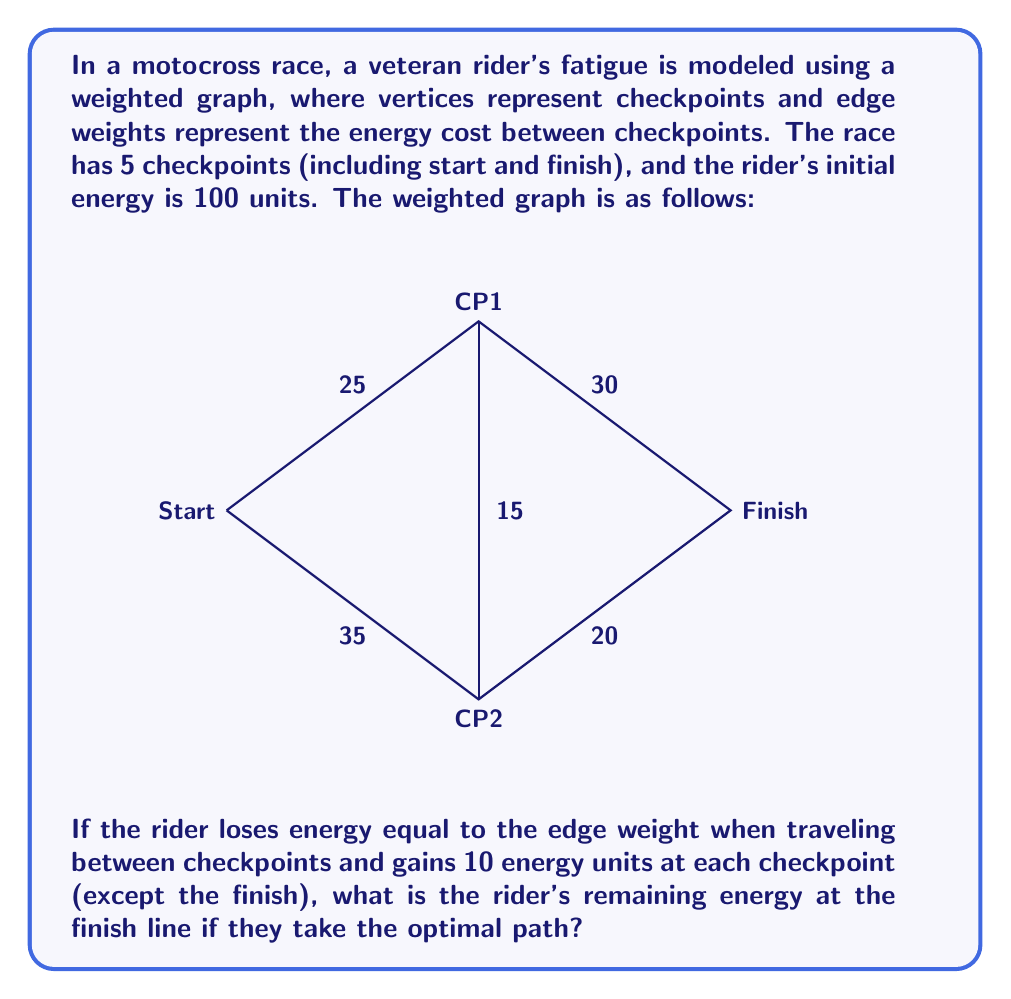Give your solution to this math problem. Let's approach this step-by-step:

1) First, we need to find the optimal path from Start to Finish. We can do this by considering all possible paths and their total energy costs:

   Path 1: Start -> CP1 -> Finish
   Path 2: Start -> CP1 -> CP2 -> Finish
   Path 3: Start -> CP2 -> Finish
   Path 4: Start -> CP2 -> CP1 -> Finish

2) Let's calculate the energy cost for each path:

   Path 1: 25 + 30 = 55
   Path 2: 25 + 15 + 20 = 60
   Path 3: 35 + 20 = 55
   Path 4: 35 + 15 + 30 = 80

3) Paths 1 and 3 have the lowest energy cost of 55. We'll choose Path 1 (Start -> CP1 -> Finish) as our optimal path.

4) Now, let's calculate the rider's energy throughout the race:

   Initial energy: 100

   After reaching CP1:
   $100 - 25 + 10 = 85$ (lost 25 energy, gained 10 at checkpoint)

   After reaching Finish:
   $85 - 30 = 55$

Therefore, the rider's remaining energy at the finish line is 55 units.
Answer: 55 energy units 